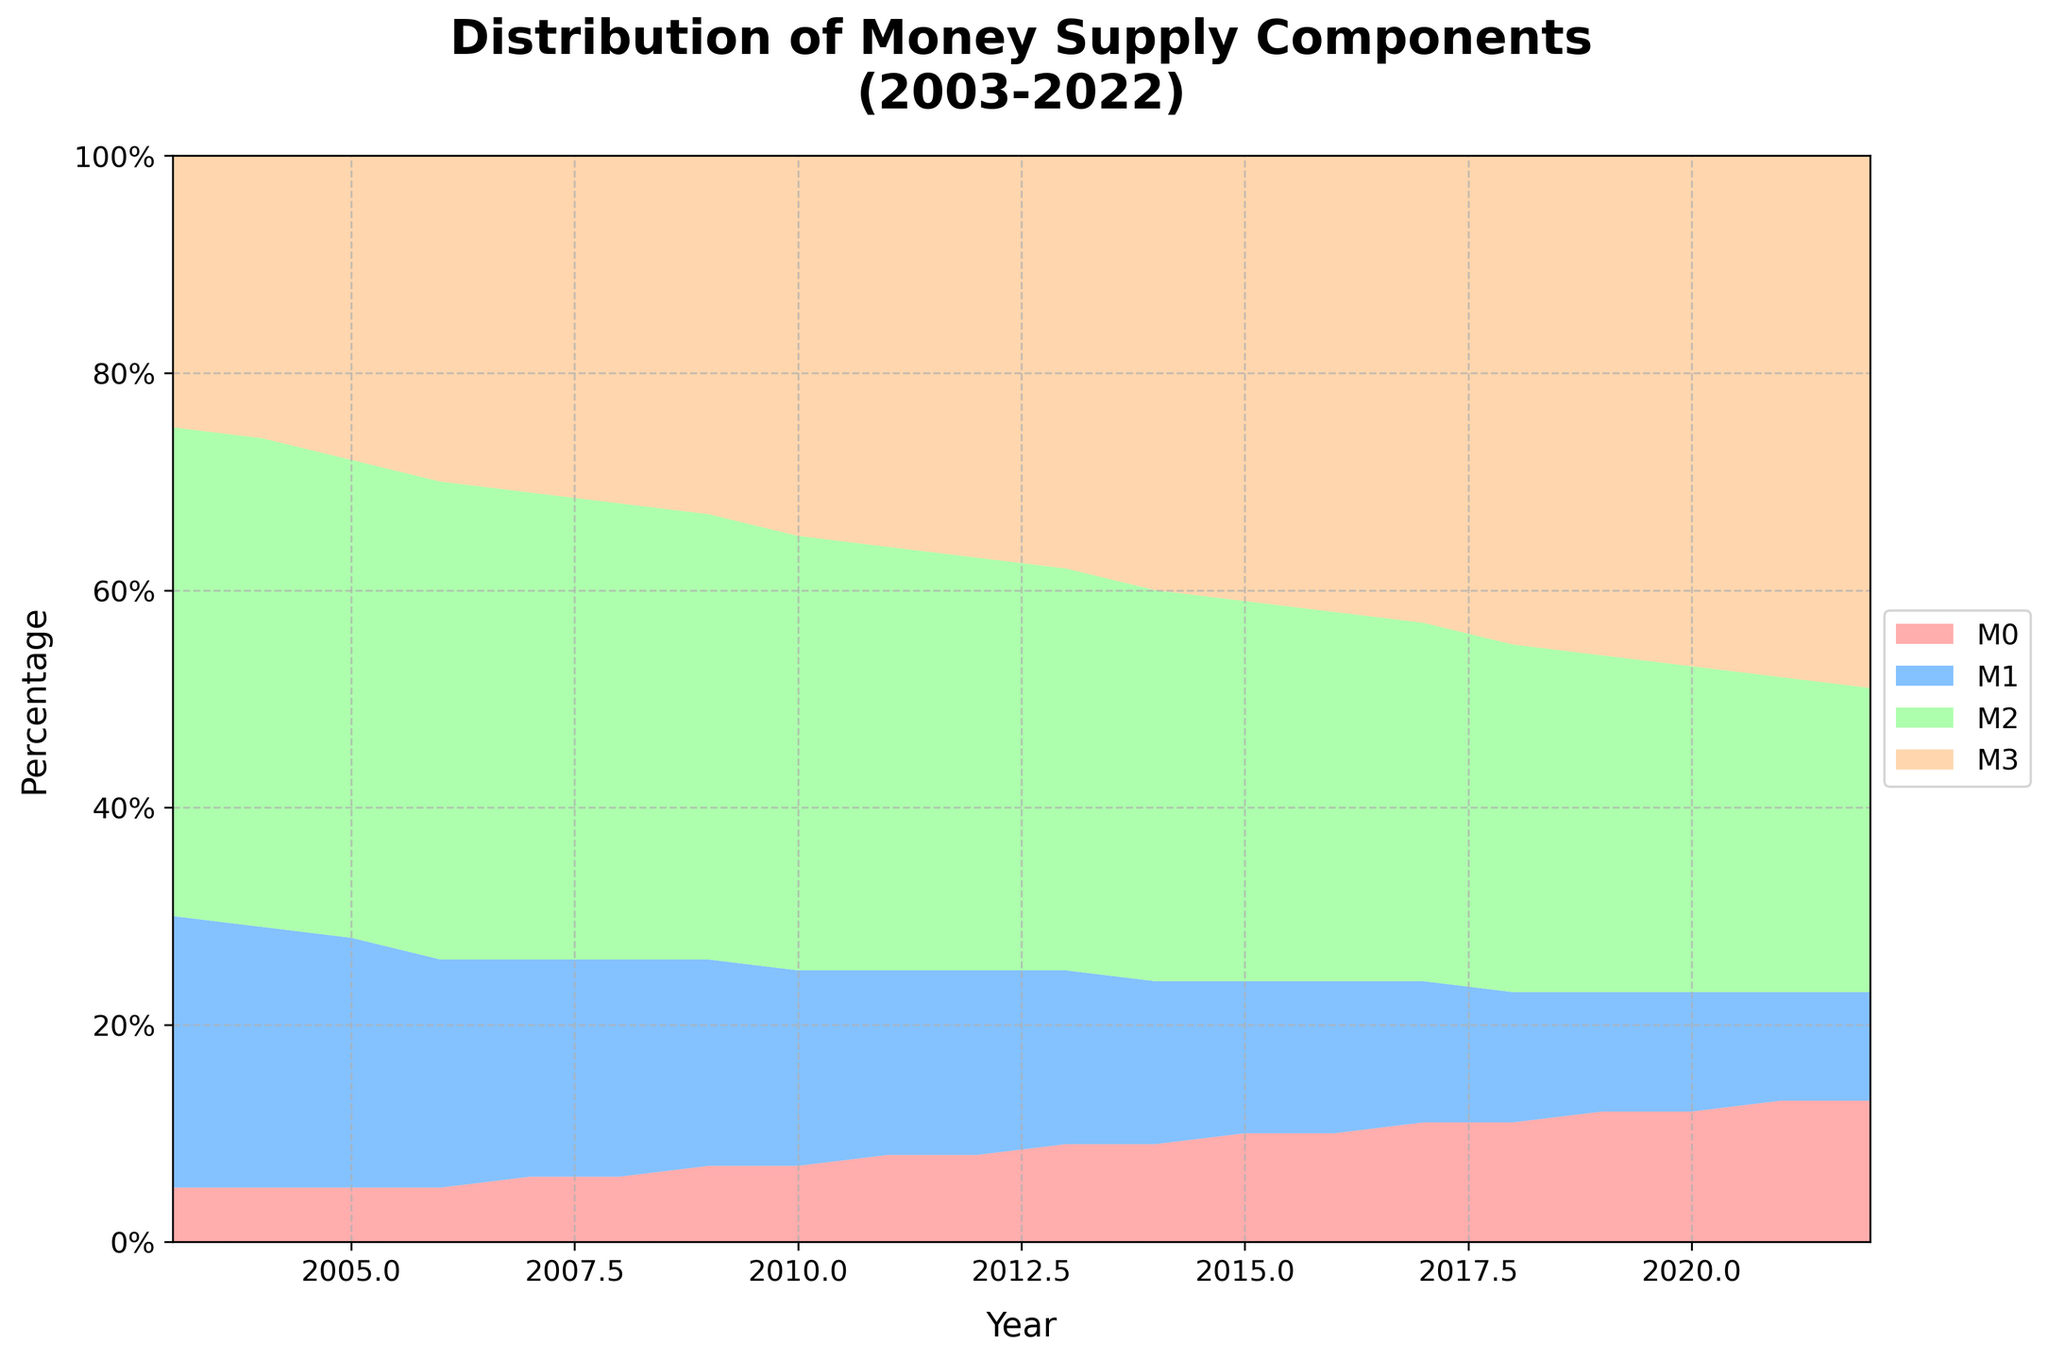How is the title of the figure phrased? The title of the figure is prominently displayed at the top and reads "Distribution of Money Supply Components (2003-2022)"
Answer: Distribution of Money Supply Components (2003-2022) Which money supply component has the smallest percentage overall? By looking at the heights of the different colored areas, the M0 component consistently occupies the smallest space at the bottom of the stacked area chart.
Answer: M0 How did the percentage of M1 change from 2003 to 2022? To determine this, look at the height of the M1's area near the start (2003) and near the end (2022). In 2003, M1 was at 25%, and by 2022 it has decreased to 10%.
Answer: Decreased by 15% During which year did M2 have the largest percentage? This requires inspecting the green area (M2) layer heights over the years. In 2003, M2 occupies 45%, and this gradually decreases.
Answer: 2003 What happened to M3 as a percentage of the total money supply over the years? M3, represented by the topmost layer, shows a rising trend starting from 25% in 2003 to 49% in 2022.
Answer: Increased significantly Compare the percentage of M0 in 2003 and 2022. Check the height of the bottom layer (M0) at both points in time. In 2003, M0 is 5%, and in 2022, it is 13%.
Answer: Increased by 8% What is the sum of percentages for M0 and M1 in 2010? M0 is 7% and M1 is 18% in 2010. Summing both gives 7% + 18% = 25%.
Answer: 25% Which component showed the most consistent percentage over the 20 years? By observing the four layers, M2 shows the most consistent percentage, starting at 45% and gradually reducing to 28% without significant fluctuations.
Answer: M2 Did any of the components cross at any point during the period? From the chart, none of the components' boundaries intersects or crosses over each other during the depicted period.
Answer: No At what year did M3 first surpass 40%? By tracking the topmost layer (M3), it can be observed that M3 first surpasses 40% in 2014.
Answer: 2014 